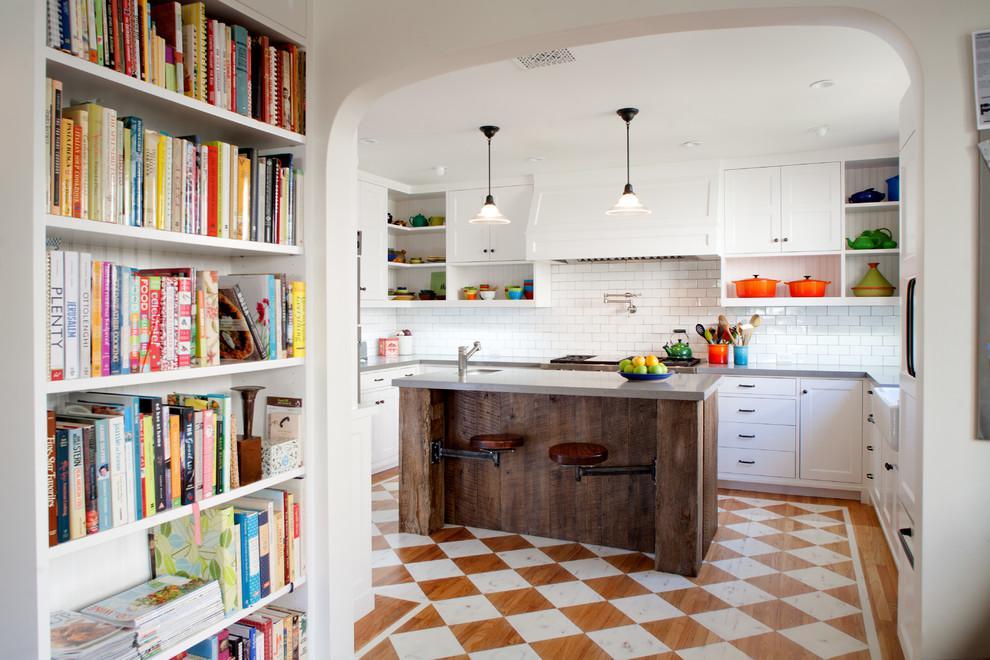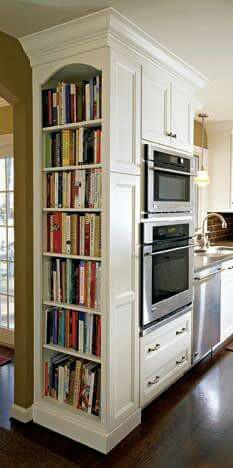The first image is the image on the left, the second image is the image on the right. Assess this claim about the two images: "In one of the images, a doorway with a view into another room is to the right of a tall white bookcase full of books that are mostly arranged vertically.". Correct or not? Answer yes or no. Yes. The first image is the image on the left, the second image is the image on the right. For the images shown, is this caption "In at least one image there is a white bookshelf that is part of a kitchen that include silver appliances." true? Answer yes or no. Yes. 